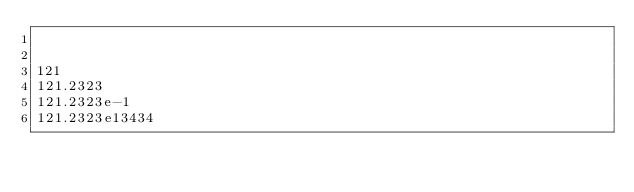<code> <loc_0><loc_0><loc_500><loc_500><_MoonScript_>

121
121.2323
121.2323e-1
121.2323e13434</code> 